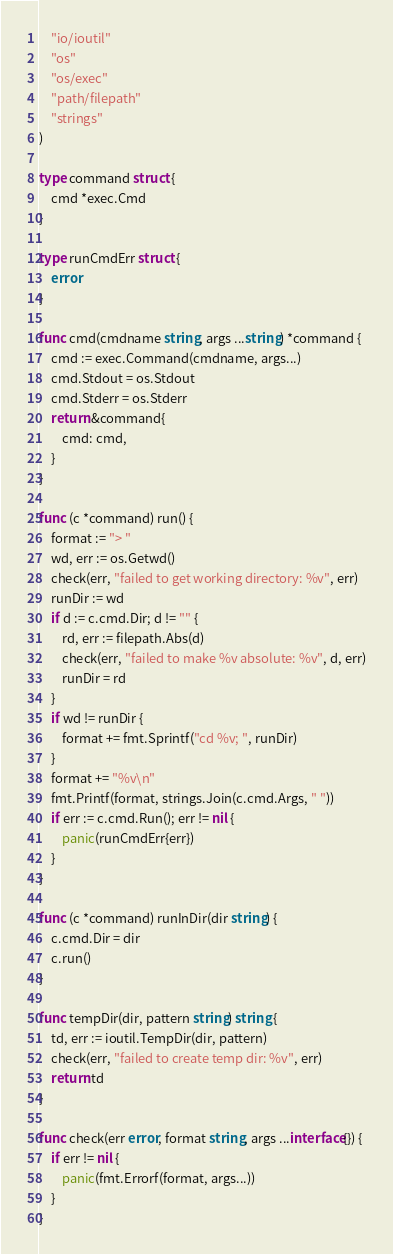Convert code to text. <code><loc_0><loc_0><loc_500><loc_500><_Go_>	"io/ioutil"
	"os"
	"os/exec"
	"path/filepath"
	"strings"
)

type command struct {
	cmd *exec.Cmd
}

type runCmdErr struct {
	error
}

func cmd(cmdname string, args ...string) *command {
	cmd := exec.Command(cmdname, args...)
	cmd.Stdout = os.Stdout
	cmd.Stderr = os.Stderr
	return &command{
		cmd: cmd,
	}
}

func (c *command) run() {
	format := "> "
	wd, err := os.Getwd()
	check(err, "failed to get working directory: %v", err)
	runDir := wd
	if d := c.cmd.Dir; d != "" {
		rd, err := filepath.Abs(d)
		check(err, "failed to make %v absolute: %v", d, err)
		runDir = rd
	}
	if wd != runDir {
		format += fmt.Sprintf("cd %v; ", runDir)
	}
	format += "%v\n"
	fmt.Printf(format, strings.Join(c.cmd.Args, " "))
	if err := c.cmd.Run(); err != nil {
		panic(runCmdErr{err})
	}
}

func (c *command) runInDir(dir string) {
	c.cmd.Dir = dir
	c.run()
}

func tempDir(dir, pattern string) string {
	td, err := ioutil.TempDir(dir, pattern)
	check(err, "failed to create temp dir: %v", err)
	return td
}

func check(err error, format string, args ...interface{}) {
	if err != nil {
		panic(fmt.Errorf(format, args...))
	}
}
</code> 